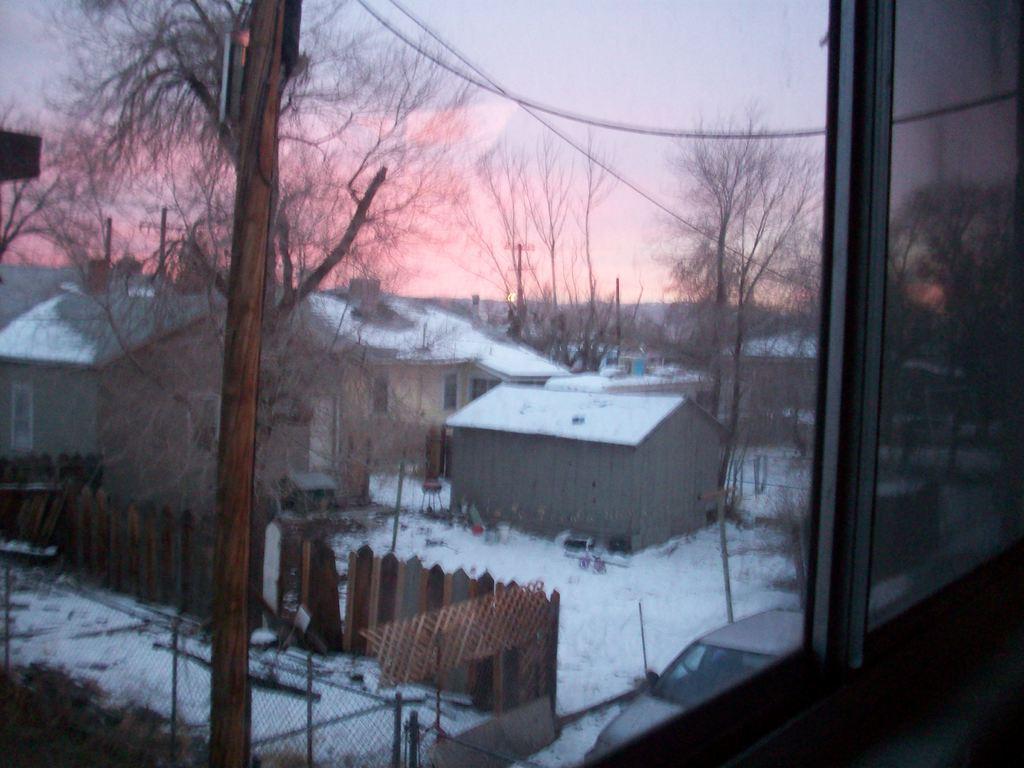Please provide a concise description of this image. In this image we can see glass. Through the glass we can see houses, snow, fence, trees, mesh, poles, and sky. 